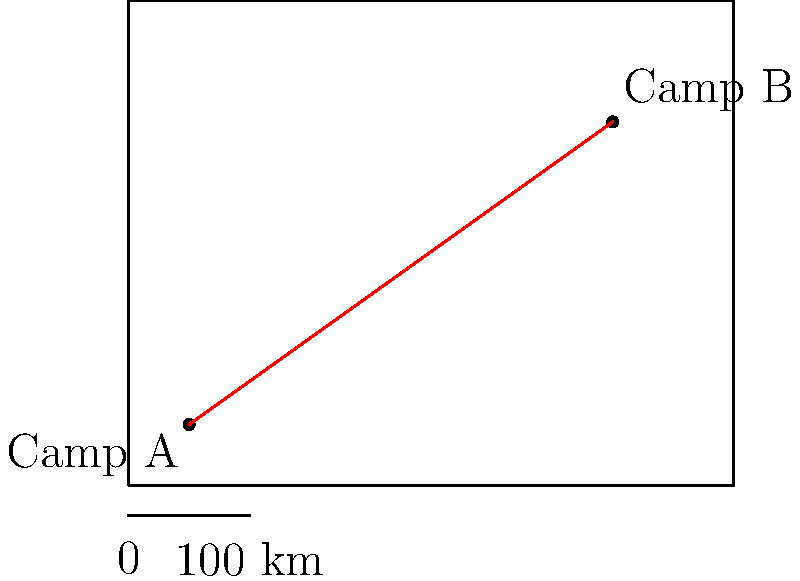Using the map and scale provided, estimate the distance between Camp A and Camp B. To estimate the distance between Camp A and Camp B, we'll follow these steps:

1. Observe the scale: 2 units on the map represent 100 km in reality.

2. Measure the distance between Camp A and Camp B on the map:
   We can see that the line connecting the camps is approximately 7 units long.

3. Set up a proportion:
   $\frac{2 \text{ units}}{100 \text{ km}} = \frac{7 \text{ units}}{x \text{ km}}$

4. Cross multiply:
   $2x = 700$

5. Solve for $x$:
   $x = \frac{700}{2} = 350$

Therefore, the estimated distance between Camp A and Camp B is approximately 350 km.
Answer: 350 km 